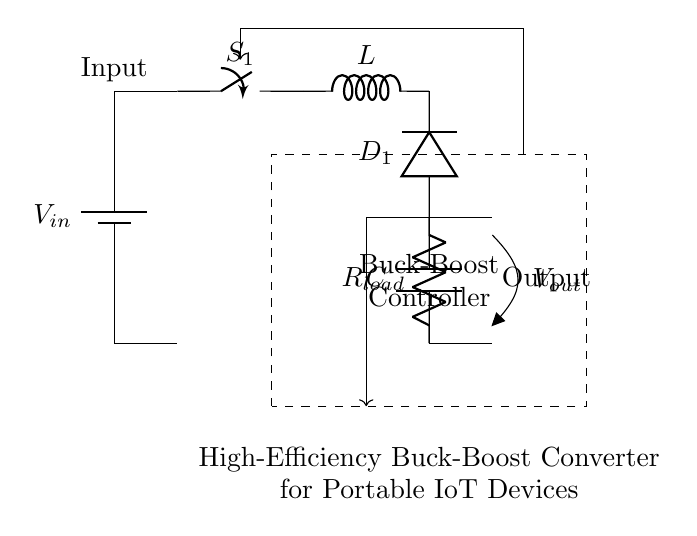What is the input component in this circuit? The input component is a battery, which is labeled as V in the diagram and provides power to the circuit.
Answer: Battery What type of converter is being represented? The circuit is a buck-boost converter, which is indicated in the description below the circuit diagram. It converts voltage up or down depending on the input.
Answer: Buck-Boost What function does the switch serve in this circuit? The switch allows or interrupts the current flow in the circuit, controlling the energy transfer to the inductor and ultimately regulating the output voltage.
Answer: Control current What is the load resistance denoted as? The load resistance in the circuit is labeled as R load, which connects to the output of the converter, indicating the component being powered by the circuit.
Answer: R load How many main energy storage components are in this circuit? There are two main energy storage components: one inductor and one capacitor, crucial for the operation of the buck-boost converter.
Answer: Two What does the dashed rectangle represent in the circuit? The dashed rectangle represents the buck-boost controller, which regulates the energy conversion process, ensuring output stability and efficiency in response to varying loads.
Answer: Buck-Boost Controller What is the primary purpose of the diode in this circuit? The diode allows current to flow in one direction only, preventing backflow and ensuring that energy is directed towards the load, thus aiding in the conversion process.
Answer: Prevent backflow 